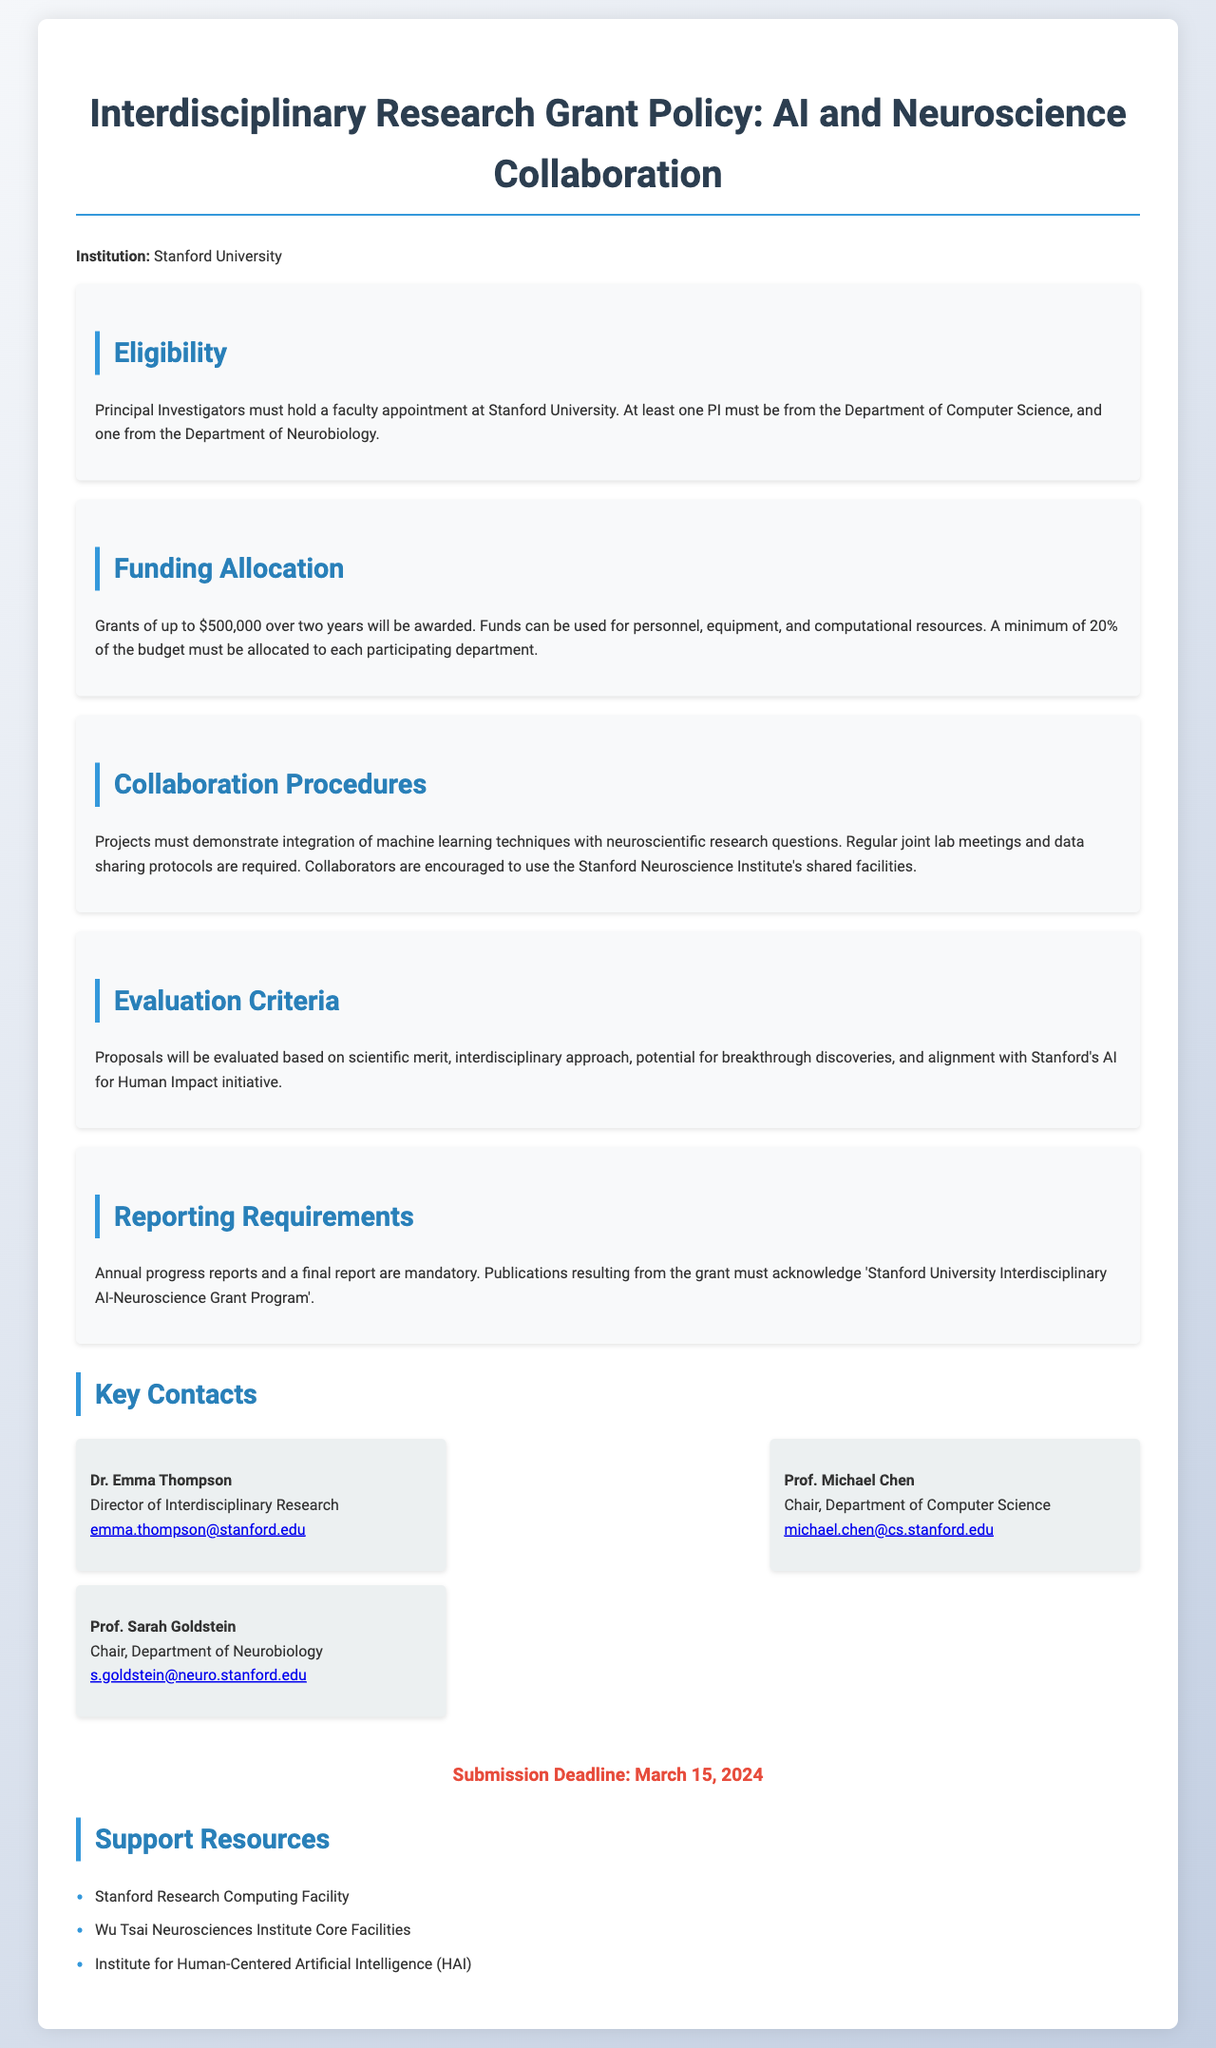what is the maximum grant amount? The maximum grant amount stated in the document is $500,000.
Answer: $500,000 who must be a Principal Investigator? A Principal Investigator must hold a faculty appointment at Stanford University and includes one from the Department of Computer Science and one from the Department of Neurobiology.
Answer: Faculty from Computer Science and Neurobiology how many years can the grant be awarded for? The grant can be awarded for a period of two years.
Answer: Two years what is the minimum budget allocation for each department? The document specifies that a minimum of 20% of the budget must be allocated to each participating department.
Answer: 20% what are the required collaboration practices for projects? Projects must demonstrate integration of machine learning techniques with neuroscientific research questions, with regular joint lab meetings and data sharing protocols.
Answer: Integration of techniques, joint meetings, data sharing who is the director of Interdisciplinary Research? The document lists Dr. Emma Thompson as the Director of Interdisciplinary Research.
Answer: Dr. Emma Thompson what is the submission deadline for the grant applications? The deadline for submission is clearly stated in the document as March 15, 2024.
Answer: March 15, 2024 which facilities are mentioned as support resources? The support resources include Stanford Research Computing Facility, Wu Tsai Neurosciences Institute Core Facilities, and Institute for Human-Centered Artificial Intelligence (HAI).
Answer: Stanford Research Computing Facility, Wu Tsai Neurosciences Institute Core Facilities, HAI 